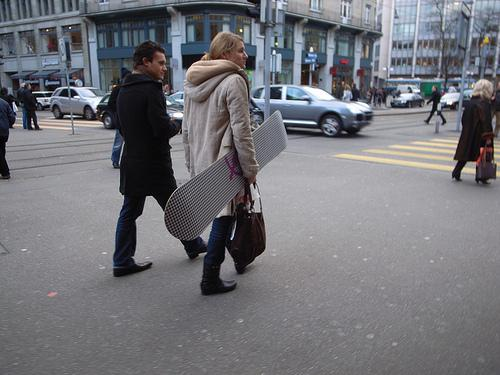Question: how many snowboards?
Choices:
A. 1.
B. 2.
C. 3.
D. 4.
Answer with the letter. Answer: A Question: what is she wearing?
Choices:
A. A necklace.
B. A pair of awesome stilettos.
C. A jacket.
D. A pair of headphones.
Answer with the letter. Answer: C Question: when will they cross?
Choices:
A. Now.
B. In a minute.
C. When there isn't anyone around.
D. At 3:00pm.
Answer with the letter. Answer: A Question: who is crossing?
Choices:
A. A man in a bright pink shirt.
B. A cow.
C. Linda Perry.
D. People.
Answer with the letter. Answer: D Question: what color are the strips?
Choices:
A. Red.
B. White.
C. Yellow.
D. Blue.
Answer with the letter. Answer: C 